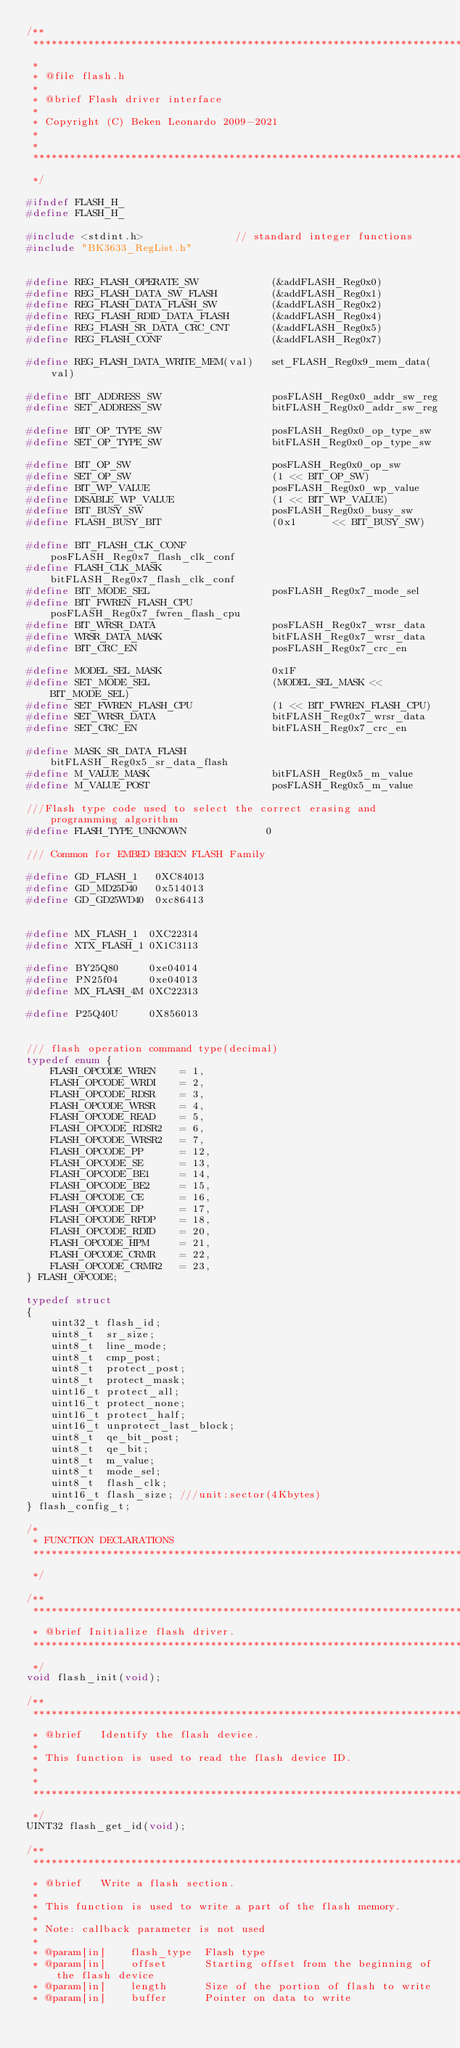<code> <loc_0><loc_0><loc_500><loc_500><_C_>/**
 ****************************************************************************************
 *
 * @file flash.h
 *
 * @brief Flash driver interface
 *
 * Copyright (C) Beken Leonardo 2009-2021
 *
 *
 ****************************************************************************************
 */

#ifndef FLASH_H_
#define FLASH_H_

#include <stdint.h>               // standard integer functions
#include "BK3633_RegList.h"


#define REG_FLASH_OPERATE_SW            (&addFLASH_Reg0x0)
#define REG_FLASH_DATA_SW_FLASH         (&addFLASH_Reg0x1)
#define REG_FLASH_DATA_FLASH_SW         (&addFLASH_Reg0x2)
#define REG_FLASH_RDID_DATA_FLASH       (&addFLASH_Reg0x4)
#define REG_FLASH_SR_DATA_CRC_CNT       (&addFLASH_Reg0x5)
#define REG_FLASH_CONF                  (&addFLASH_Reg0x7)

#define REG_FLASH_DATA_WRITE_MEM(val)   set_FLASH_Reg0x9_mem_data(val)

#define BIT_ADDRESS_SW                  posFLASH_Reg0x0_addr_sw_reg
#define SET_ADDRESS_SW                  bitFLASH_Reg0x0_addr_sw_reg

#define BIT_OP_TYPE_SW                  posFLASH_Reg0x0_op_type_sw
#define SET_OP_TYPE_SW                  bitFLASH_Reg0x0_op_type_sw

#define BIT_OP_SW                       posFLASH_Reg0x0_op_sw
#define SET_OP_SW                       (1 << BIT_OP_SW)
#define BIT_WP_VALUE                    posFLASH_Reg0x0_wp_value
#define DISABLE_WP_VALUE                (1 << BIT_WP_VALUE)
#define BIT_BUSY_SW                     posFLASH_Reg0x0_busy_sw
#define FLASH_BUSY_BIT                  (0x1      << BIT_BUSY_SW)

#define BIT_FLASH_CLK_CONF              posFLASH_Reg0x7_flash_clk_conf
#define FLASH_CLK_MASK                  bitFLASH_Reg0x7_flash_clk_conf
#define BIT_MODE_SEL                    posFLASH_Reg0x7_mode_sel
#define BIT_FWREN_FLASH_CPU             posFLASH_Reg0x7_fwren_flash_cpu
#define BIT_WRSR_DATA                   posFLASH_Reg0x7_wrsr_data
#define WRSR_DATA_MASK                  bitFLASH_Reg0x7_wrsr_data
#define BIT_CRC_EN                      posFLASH_Reg0x7_crc_en

#define MODEL_SEL_MASK					0x1F
#define SET_MODE_SEL                    (MODEL_SEL_MASK << BIT_MODE_SEL)
#define SET_FWREN_FLASH_CPU             (1 << BIT_FWREN_FLASH_CPU)
#define SET_WRSR_DATA                   bitFLASH_Reg0x7_wrsr_data
#define SET_CRC_EN                      bitFLASH_Reg0x7_crc_en

#define MASK_SR_DATA_FLASH              bitFLASH_Reg0x5_sr_data_flash
#define M_VALUE_MASK					bitFLASH_Reg0x5_m_value
#define M_VALUE_POST					posFLASH_Reg0x5_m_value

///Flash type code used to select the correct erasing and programming algorithm
#define FLASH_TYPE_UNKNOWN             0

/// Common for EMBED BEKEN FLASH Family

#define GD_FLASH_1	 0XC84013
#define GD_MD25D40   0x514013
#define GD_GD25WD40  0xc86413


#define MX_FLASH_1	0XC22314
#define XTX_FLASH_1	0X1C3113

#define BY25Q80		0xe04014
#define PN25f04		0xe04013
#define MX_FLASH_4M 0XC22313

#define P25Q40U     0X856013


/// flash operation command type(decimal)
typedef enum {
	FLASH_OPCODE_WREN    = 1,
	FLASH_OPCODE_WRDI    = 2,
	FLASH_OPCODE_RDSR    = 3,
	FLASH_OPCODE_WRSR    = 4,
	FLASH_OPCODE_READ    = 5,
	FLASH_OPCODE_RDSR2   = 6,
	FLASH_OPCODE_WRSR2   = 7,
	FLASH_OPCODE_PP      = 12,
	FLASH_OPCODE_SE      = 13,
	FLASH_OPCODE_BE1     = 14,
	FLASH_OPCODE_BE2     = 15,
	FLASH_OPCODE_CE      = 16,
	FLASH_OPCODE_DP      = 17,
	FLASH_OPCODE_RFDP    = 18,
	FLASH_OPCODE_RDID    = 20,
	FLASH_OPCODE_HPM     = 21,
	FLASH_OPCODE_CRMR    = 22,
	FLASH_OPCODE_CRMR2   = 23,
} FLASH_OPCODE;

typedef struct
{
    uint32_t flash_id;
    uint8_t  sr_size;
    uint8_t  line_mode;
    uint8_t  cmp_post;
    uint8_t  protect_post;
    uint8_t  protect_mask;
    uint16_t protect_all;
    uint16_t protect_none;
    uint16_t protect_half;
    uint16_t unprotect_last_block;
    uint8_t  qe_bit_post;
    uint8_t  qe_bit;
    uint8_t  m_value;
    uint8_t  mode_sel;
    uint8_t  flash_clk;
    uint16_t flash_size; ///unit:sector(4Kbytes)
} flash_config_t;

/*
 * FUNCTION DECLARATIONS
 ****************************************************************************************
 */

/**
 ****************************************************************************************
 * @brief Initialize flash driver.
 ****************************************************************************************
 */
void flash_init(void);

/**
 ****************************************************************************************
 * @brief   Identify the flash device.
 *
 * This function is used to read the flash device ID.
 * 
 *
 ****************************************************************************************
 */
UINT32 flash_get_id(void);

/**
 ****************************************************************************************
 * @brief   Write a flash section.
 *
 * This function is used to write a part of the flash memory.
 * 
 * Note: callback parameter is not used
 *
 * @param[in]    flash_type  Flash type
 * @param[in]    offset      Starting offset from the beginning of the flash device
 * @param[in]    length      Size of the portion of flash to write
 * @param[in]    buffer      Pointer on data to write</code> 